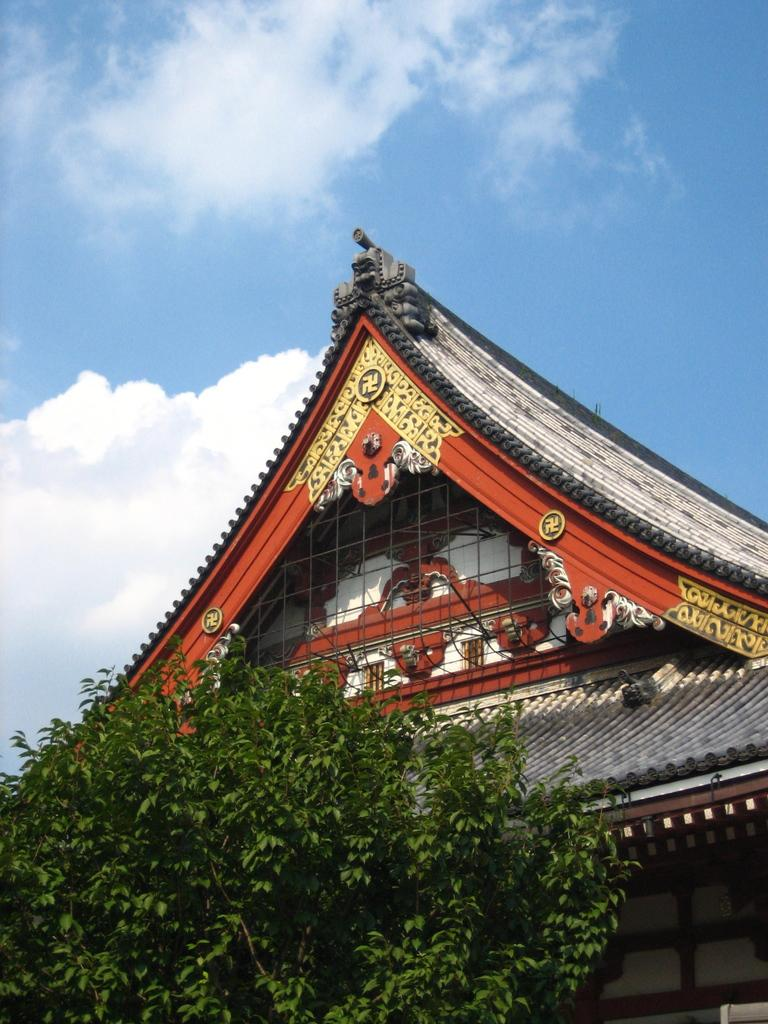What is located at the bottom of the image? There is a tree and a building at the bottom of the image. What can be seen in the sky in the image? The sky is visible at the top of the image, and clouds are present in the sky. Can you tell me how many insects are sitting on the tree in the image? There are no insects present in the image; it only features a tree and a building at the bottom, with clouds in the sky. Is there a scarf hanging from the tree in the image? There is no scarf present in the image; it only features a tree and a building at the bottom, with clouds in the sky. 